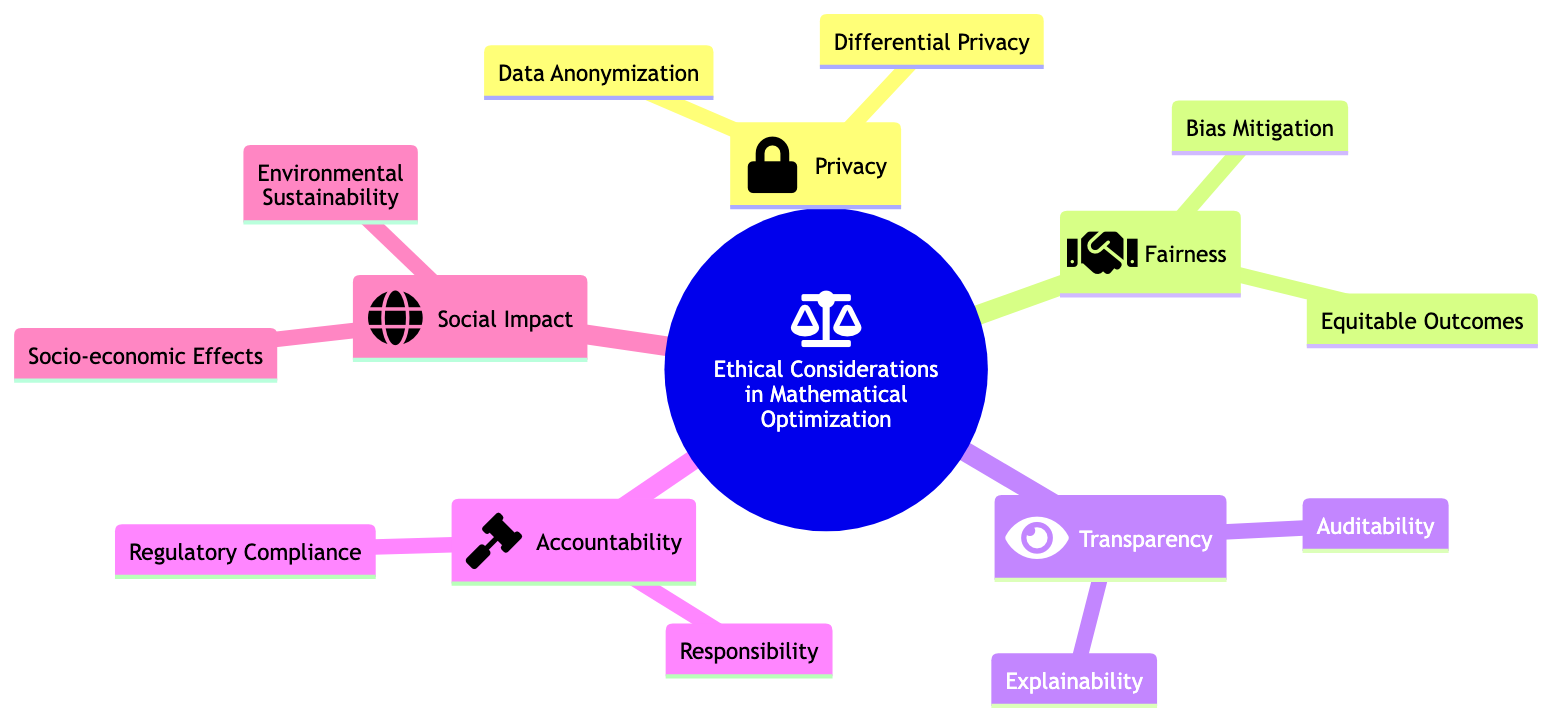What are the main categories under "Ethical Considerations in Mathematical Optimization"? The diagram lists five main categories: Privacy, Fairness, Transparency, Accountability, and Social Impact. These are the top-level nodes connected to the root node.
Answer: Privacy, Fairness, Transparency, Accountability, Social Impact How many subcategories are listed under "Accountability"? There are two subcategories under "Accountability": Responsibility and Regulatory Compliance. By counting the nodes connected directly under the Accountability node, we can determine the total.
Answer: 2 Which subcategory is related to obscuring personal data? The subcategory related to obscuring personal data is Data Anonymization, which falls under the Privacy category. This information can be found by looking for the Privacy node's subcategories.
Answer: Data Anonymization What is the focus of the "Fairness" category? The focus of the "Fairness" category is on reducing algorithmic bias and ensuring equitable outcomes for all groups, indicated by its two subcategories. This response requires identifying the purpose of the Fairness node's subnodes.
Answer: Bias Mitigation, Equitable Outcomes Which category includes "Environmental Sustainability"? "Environmental Sustainability" is included in the Social Impact category. To find this answer, one should locate the node for Social Impact and look for its subcategories.
Answer: Social Impact 